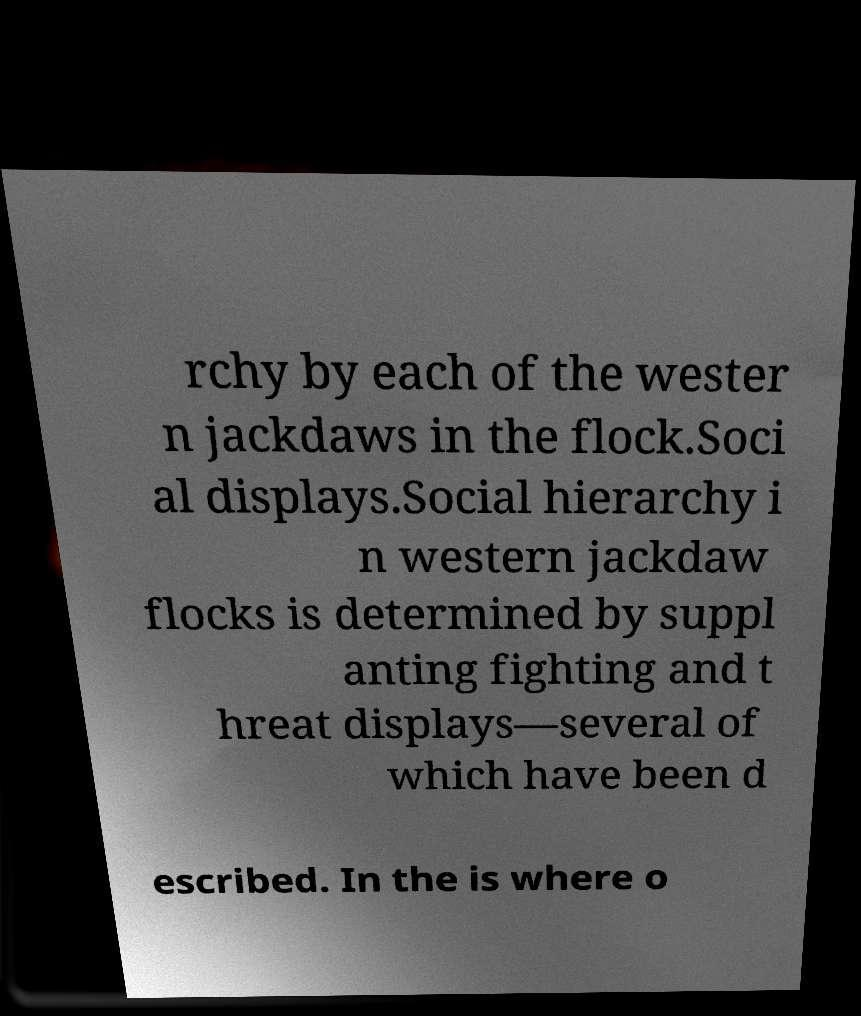Please read and relay the text visible in this image. What does it say? rchy by each of the wester n jackdaws in the flock.Soci al displays.Social hierarchy i n western jackdaw flocks is determined by suppl anting fighting and t hreat displays—several of which have been d escribed. In the is where o 